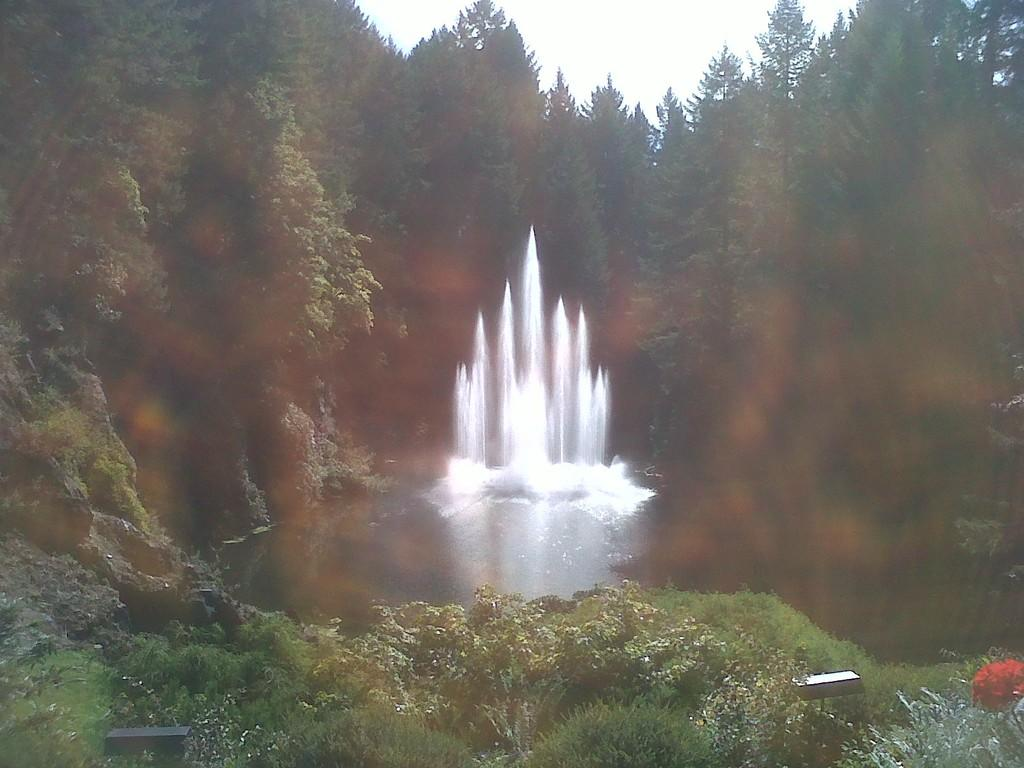What natural feature is the main subject of the image? There is a waterfall in the image. What can be seen at the base of the waterfall? Small plants are present at the bottom of the waterfall. What type of vegetation is visible in the background of the image? There are many trees in the background of the image. What is visible at the top of the image? The sky is visible at the top of the image. How does the rose in the image compare to the waterfall? There is no rose present in the image, so it cannot be compared to the waterfall. 